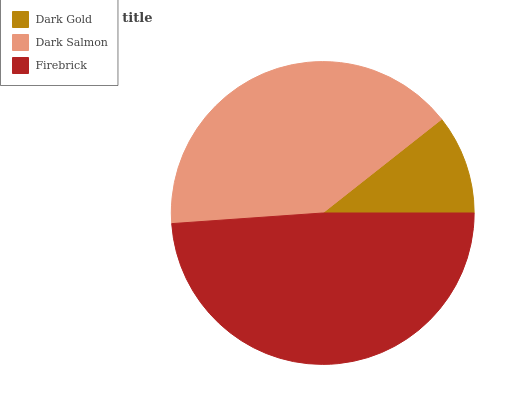Is Dark Gold the minimum?
Answer yes or no. Yes. Is Firebrick the maximum?
Answer yes or no. Yes. Is Dark Salmon the minimum?
Answer yes or no. No. Is Dark Salmon the maximum?
Answer yes or no. No. Is Dark Salmon greater than Dark Gold?
Answer yes or no. Yes. Is Dark Gold less than Dark Salmon?
Answer yes or no. Yes. Is Dark Gold greater than Dark Salmon?
Answer yes or no. No. Is Dark Salmon less than Dark Gold?
Answer yes or no. No. Is Dark Salmon the high median?
Answer yes or no. Yes. Is Dark Salmon the low median?
Answer yes or no. Yes. Is Firebrick the high median?
Answer yes or no. No. Is Dark Gold the low median?
Answer yes or no. No. 